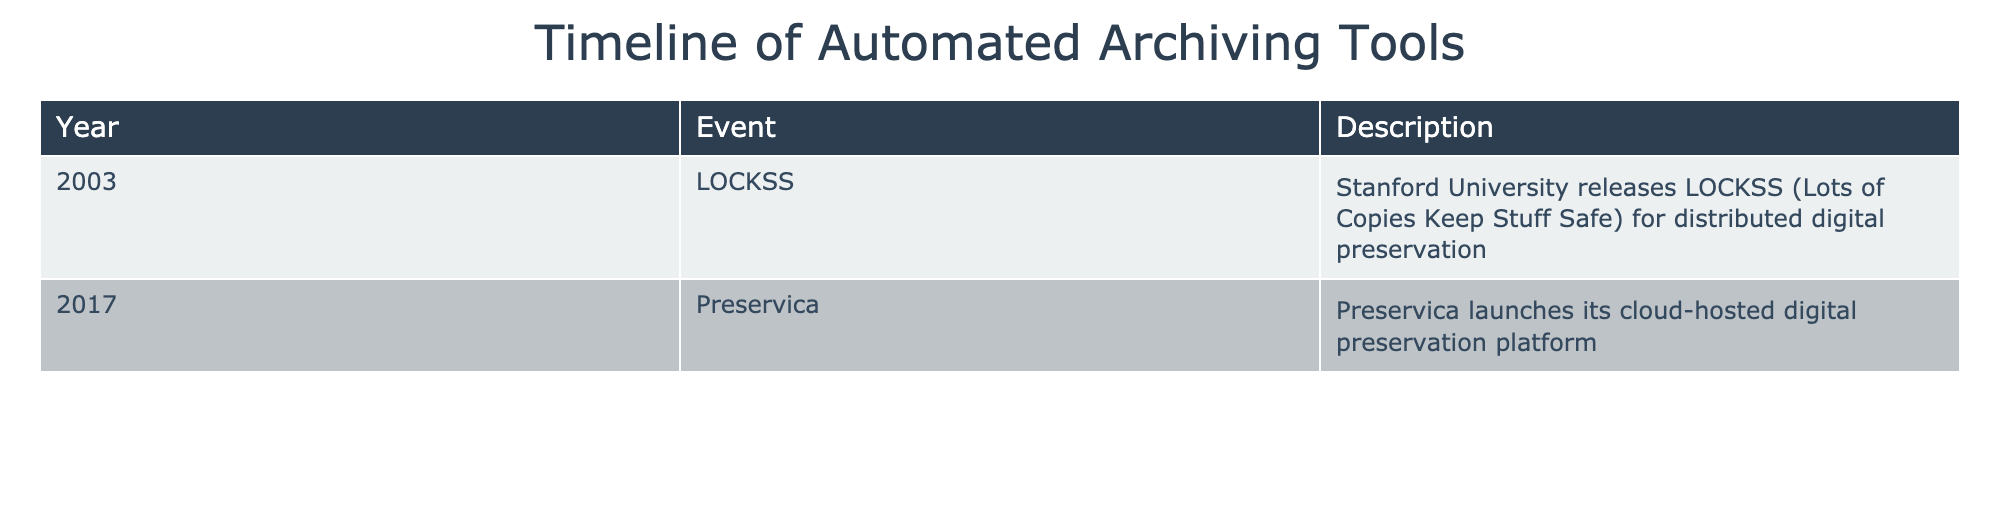What year was LOCKSS released? LOCKSS was released in 2003, as stated in the "Year" column of the table under the "Event" LOCKSS.
Answer: 2003 What is the main purpose of the LOCKSS tool? The description for LOCKSS describes it as a solution for "distributed digital preservation" which aims to keep digital content safe.
Answer: To keep digital content safe Which company launched a cloud-hosted digital preservation platform in 2017? The table indicates Preservica launched its cloud-hosted digital preservation platform in 2017 under the "Event" column.
Answer: Preservica Is LOCKSS the earliest tool listed in the table? Yes, since LOCKSS was introduced in 2003 and it is the first event recorded in the table, confirming it is the earliest tool listed.
Answer: Yes What is the difference in years between the releases of LOCKSS and Preservica? LOCKSS was released in 2003 and Preservica was launched in 2017. The difference is 2017 - 2003 = 14 years.
Answer: 14 years How many events are listed in the table? There are two events listed in the table: LOCKSS in 2003 and Preservica in 2017.
Answer: 2 events Did any tool get released before 2000 according to the table? No, the earliest event is from 2003, indicating that no tool was released before 2000.
Answer: No Which event happened later according to the timeline? By analyzing the years provided, Preservica's launch in 2017 happens later than LOCKSS from 2003.
Answer: Preservica What kind of preservation solution is referenced in the 2017 entry? The 2017 entry describes a "cloud-hosted digital preservation platform," indicating a modern approach to digital preservation.
Answer: Cloud-hosted digital preservation platform 